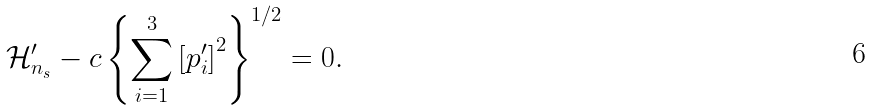Convert formula to latex. <formula><loc_0><loc_0><loc_500><loc_500>\mathcal { H } ^ { \prime } _ { n _ { s } } - c \left \{ \sum _ { i = 1 } ^ { 3 } \left [ p ^ { \prime } _ { i } \right ] ^ { 2 } \right \} ^ { 1 / 2 } & = 0 .</formula> 